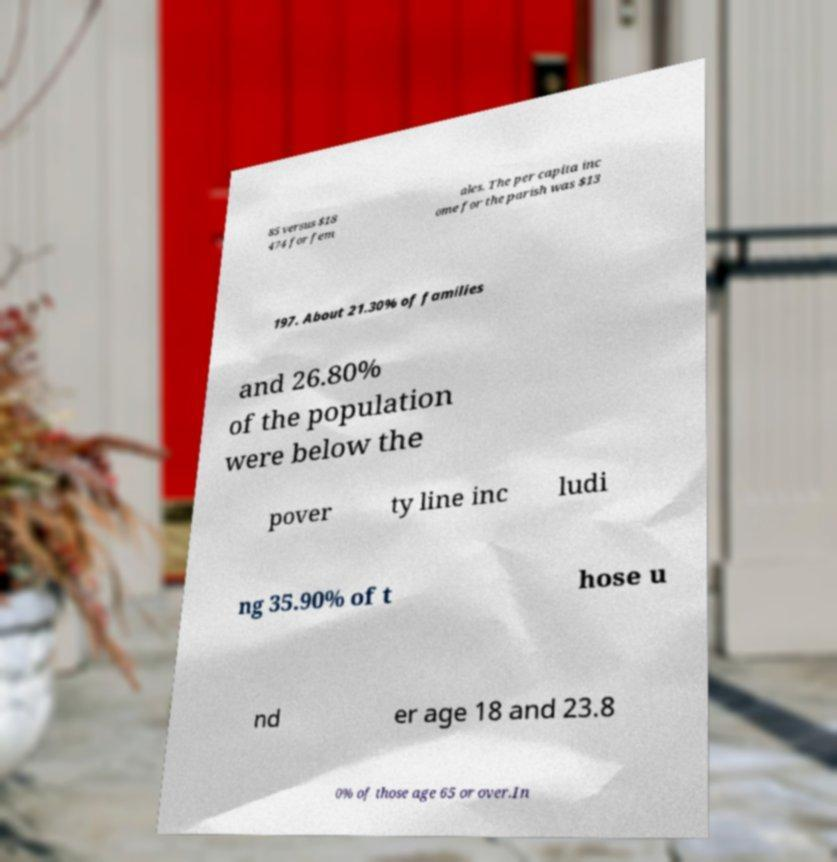I need the written content from this picture converted into text. Can you do that? 85 versus $18 474 for fem ales. The per capita inc ome for the parish was $13 197. About 21.30% of families and 26.80% of the population were below the pover ty line inc ludi ng 35.90% of t hose u nd er age 18 and 23.8 0% of those age 65 or over.In 